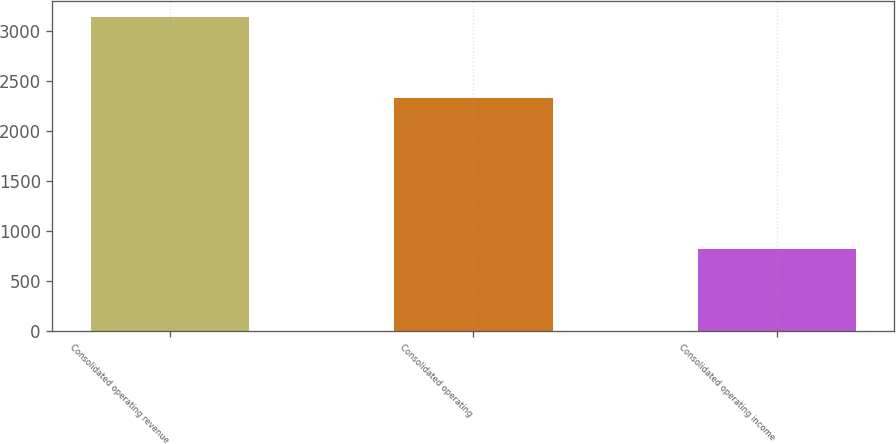Convert chart to OTSL. <chart><loc_0><loc_0><loc_500><loc_500><bar_chart><fcel>Consolidated operating revenue<fcel>Consolidated operating<fcel>Consolidated operating income<nl><fcel>3144.9<fcel>2327<fcel>817.9<nl></chart> 